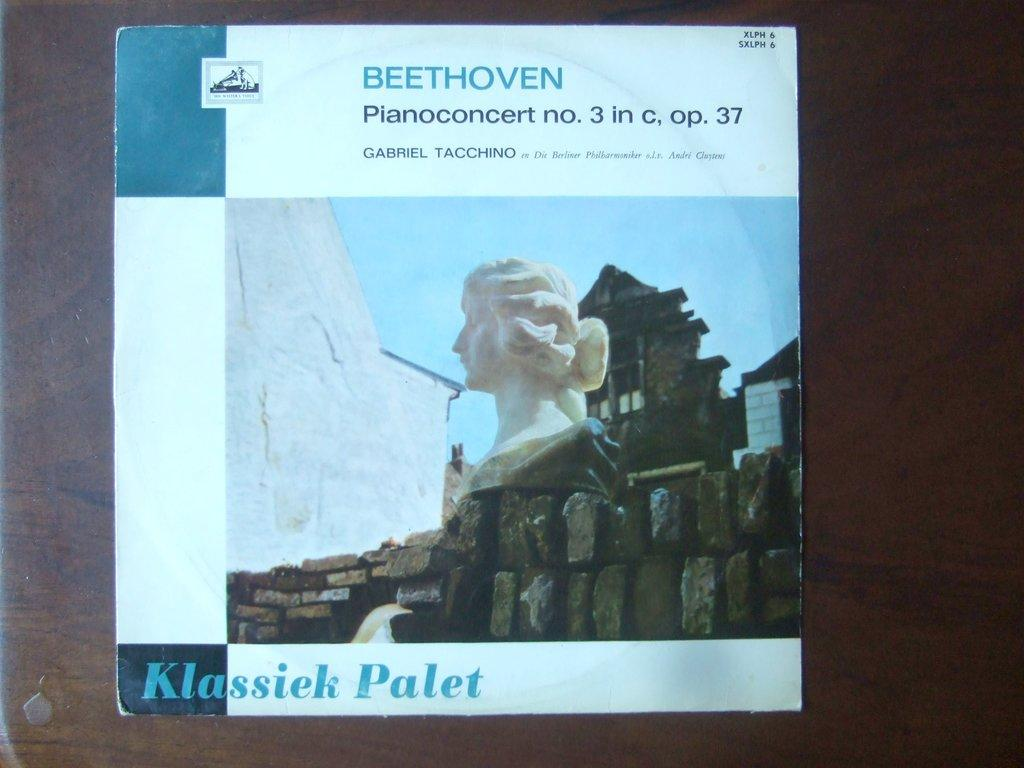What is featured in the image? There is a poster in the image. Where is the poster placed? The poster is placed over a place. What can be seen on the poster? There is a statue present on the poster. How many cars are parked on the cushion in the image? There are no cars or cushions present in the image; it features a poster with a statue. 